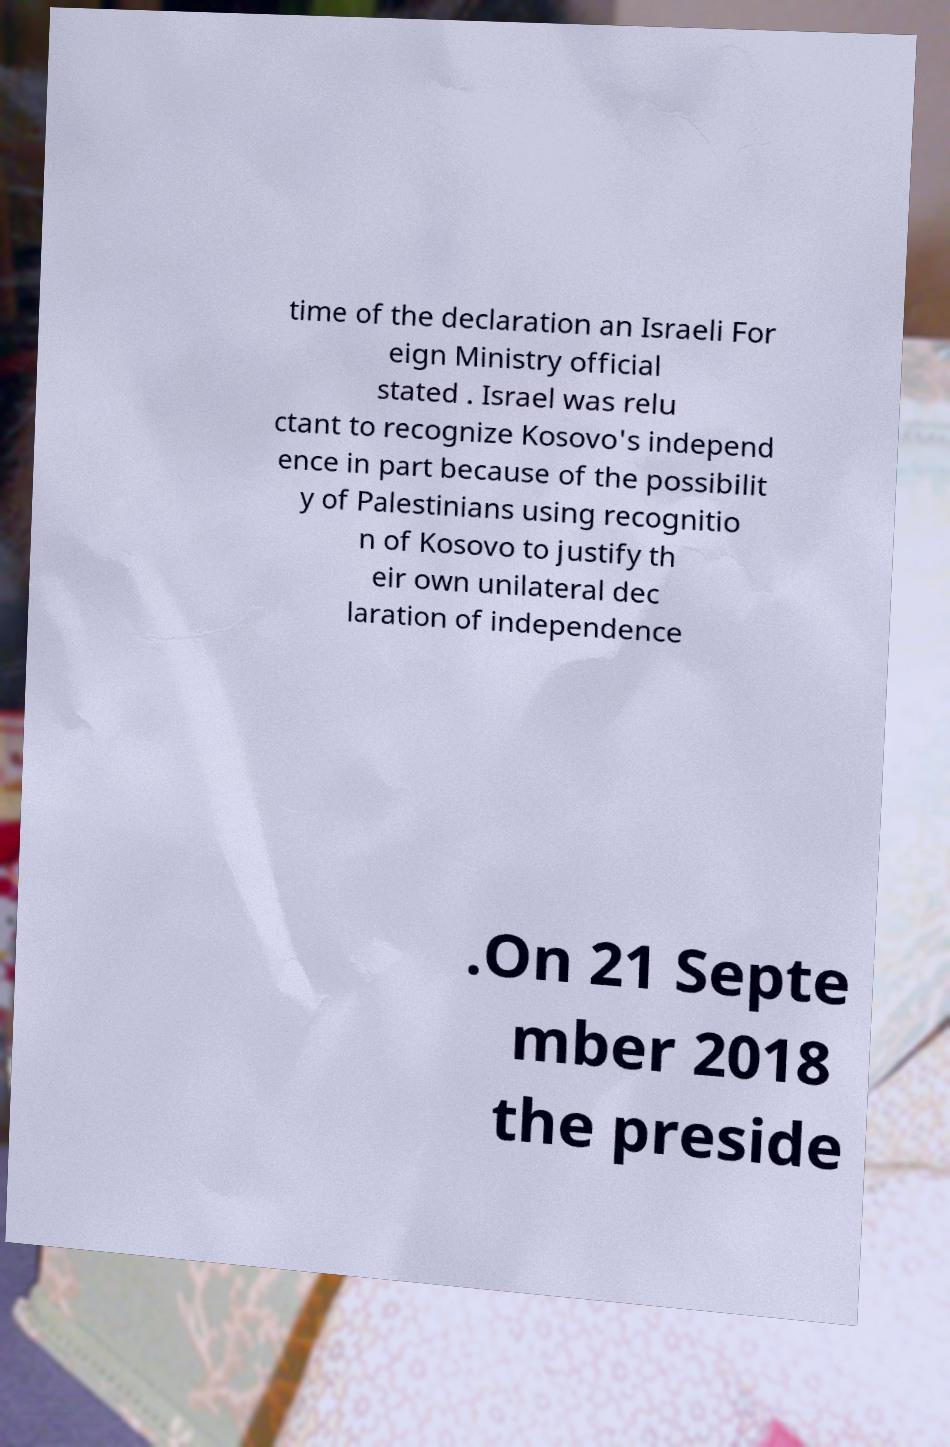Can you read and provide the text displayed in the image?This photo seems to have some interesting text. Can you extract and type it out for me? time of the declaration an Israeli For eign Ministry official stated . Israel was relu ctant to recognize Kosovo's independ ence in part because of the possibilit y of Palestinians using recognitio n of Kosovo to justify th eir own unilateral dec laration of independence .On 21 Septe mber 2018 the preside 